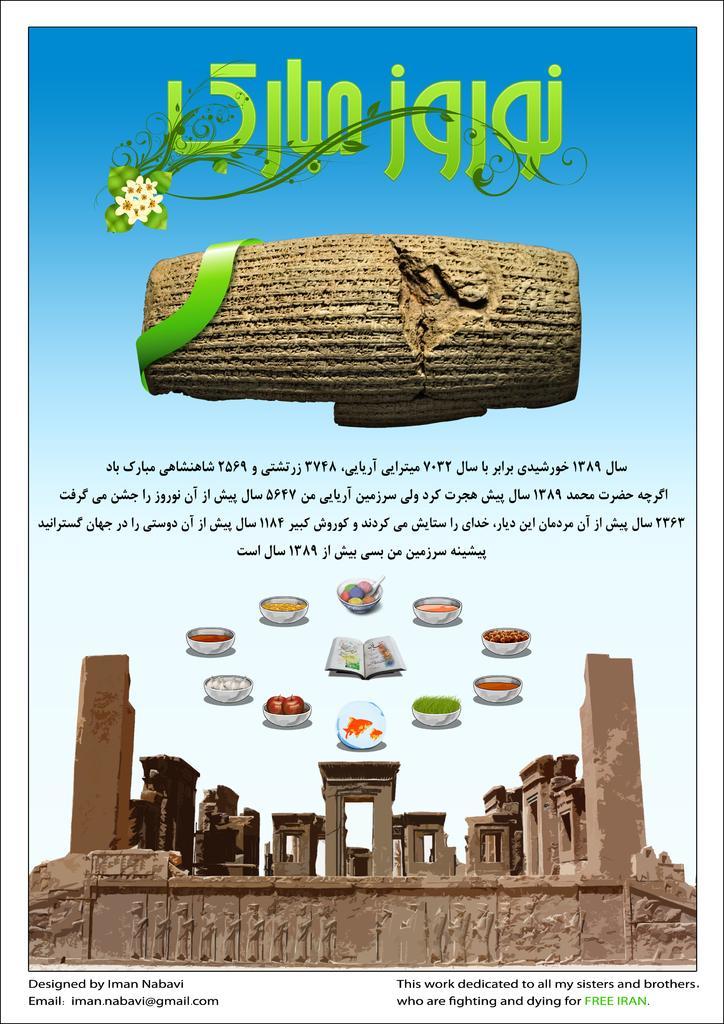In one or two sentences, can you explain what this image depicts? In this image I can see the pamphlet. In the pamphlet I can see the bowl with many food items and the book. At the down I can see the fort. I can also see the brown color object. I can also see the text written in the pamphlet. 